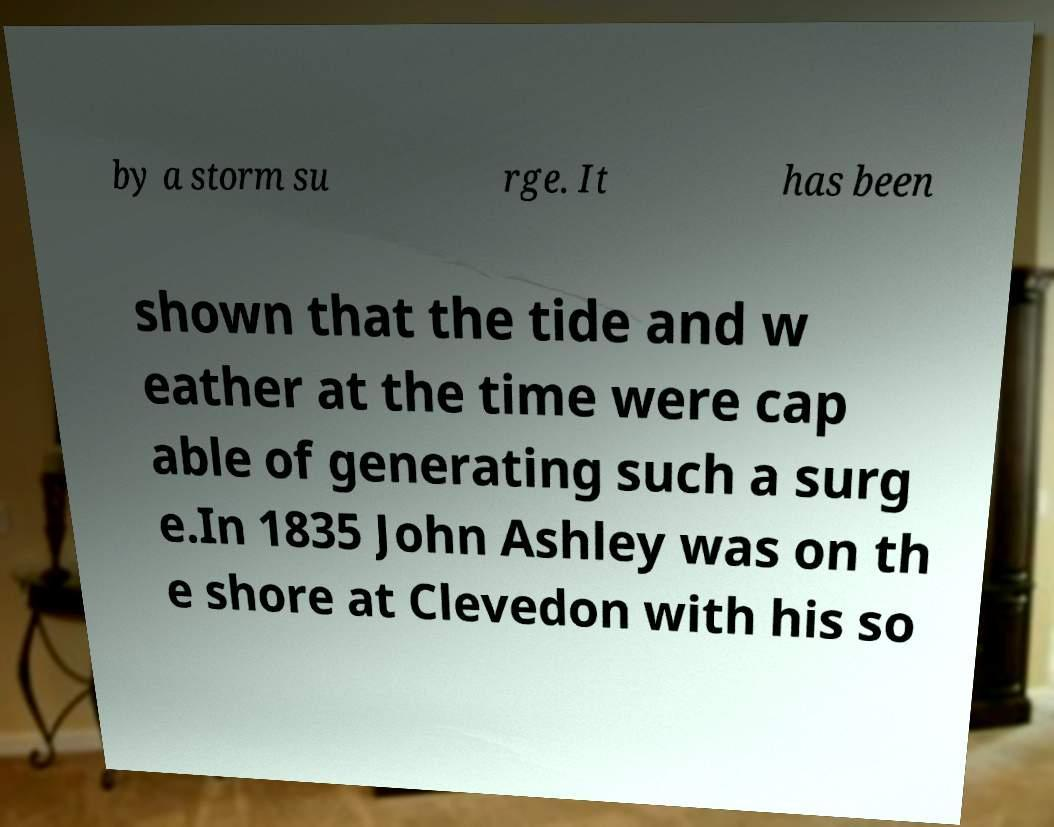I need the written content from this picture converted into text. Can you do that? by a storm su rge. It has been shown that the tide and w eather at the time were cap able of generating such a surg e.In 1835 John Ashley was on th e shore at Clevedon with his so 